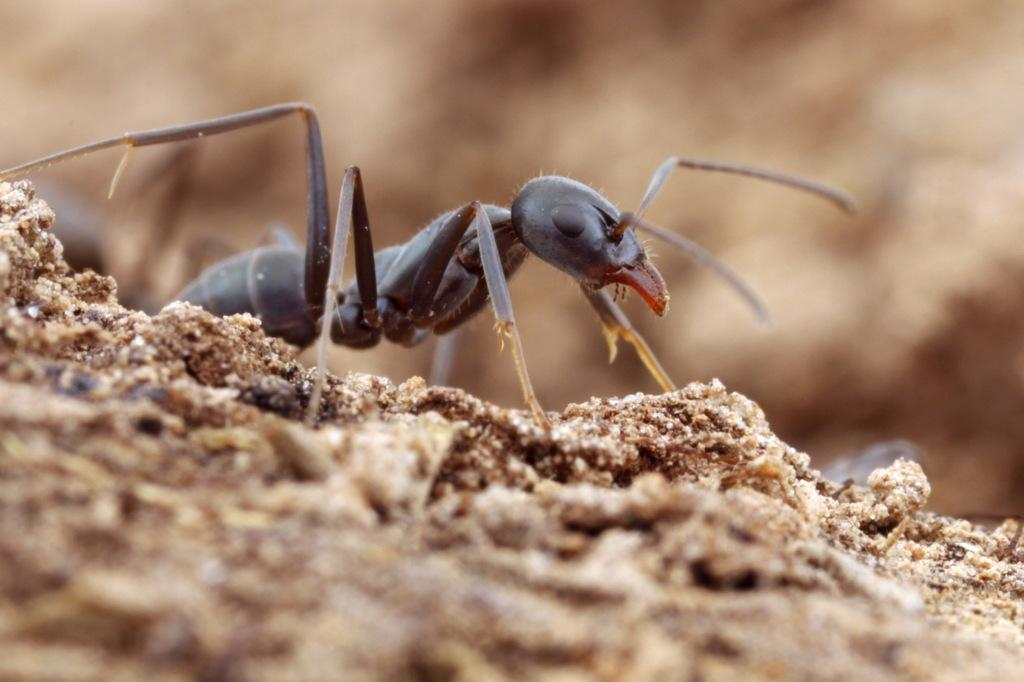What is the main subject of the image? There is an ant in the image. Where is the ant located? The ant is on the ground. Can you describe the background of the image? The background of the image is blurred. What type of gun is the ant using to pull the support in the image? There is no gun or support present in the image, and the ant is not using any tools. 